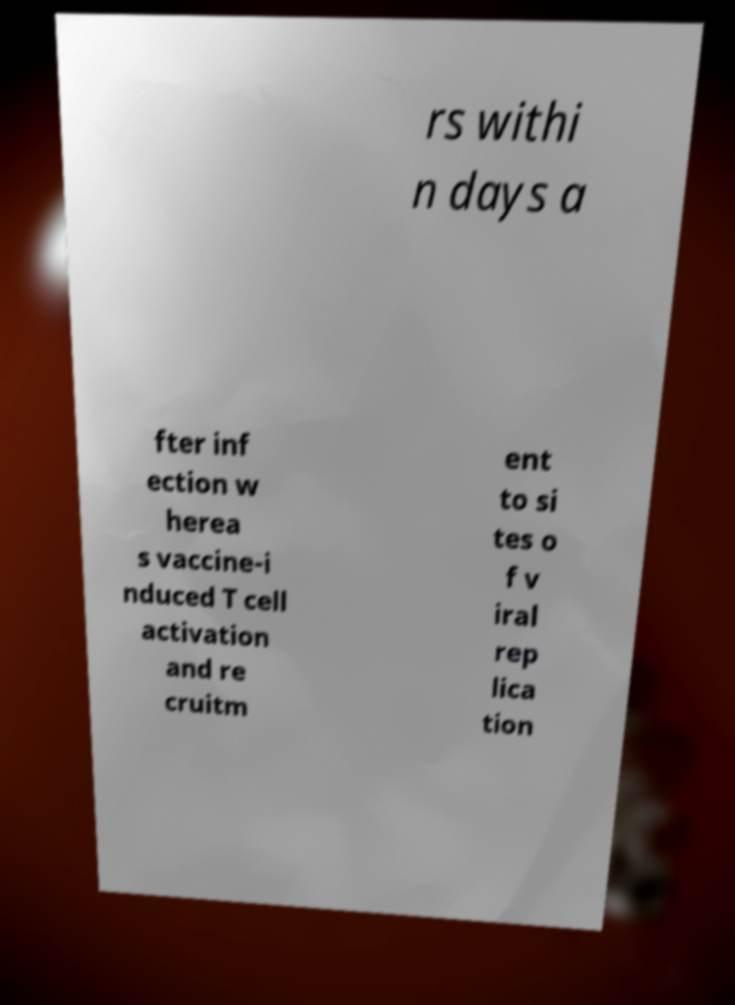Could you extract and type out the text from this image? rs withi n days a fter inf ection w herea s vaccine-i nduced T cell activation and re cruitm ent to si tes o f v iral rep lica tion 